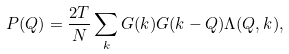<formula> <loc_0><loc_0><loc_500><loc_500>P ( Q ) = \frac { 2 T } { N } \sum _ { k } G ( k ) G ( k - Q ) \Lambda ( Q , k ) ,</formula> 